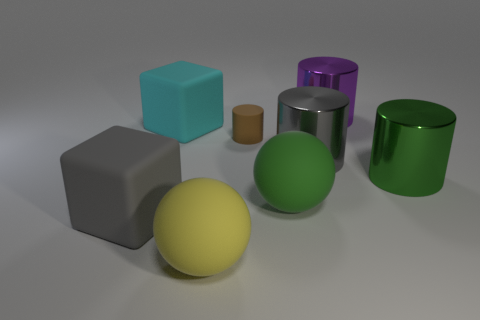How many objects are there in total and can you describe them by their colors and shapes? In total, there are six objects in the image. Starting from the left, there is a large grey matte cube, a smaller brown matte cylinder, a large green matte sphere, a large yellow matte sphere, a large purple metallic cylinder, and a large green metallic cylinder. 